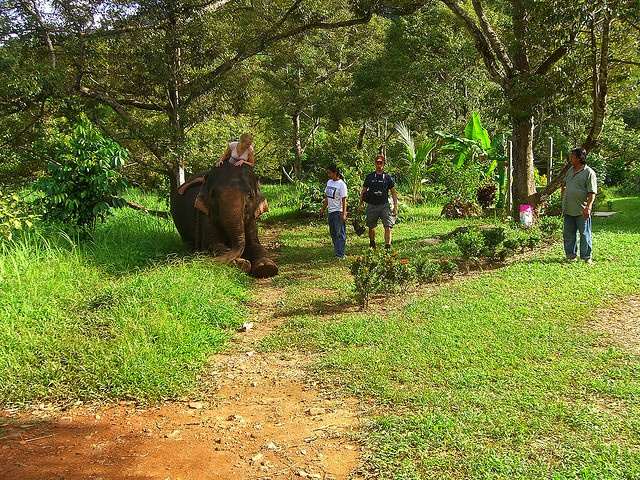Describe the objects in this image and their specific colors. I can see elephant in gray, black, maroon, and olive tones, people in gray, black, and darkgreen tones, people in gray, black, olive, and maroon tones, people in gray, black, darkgray, and maroon tones, and people in gray, maroon, and black tones in this image. 